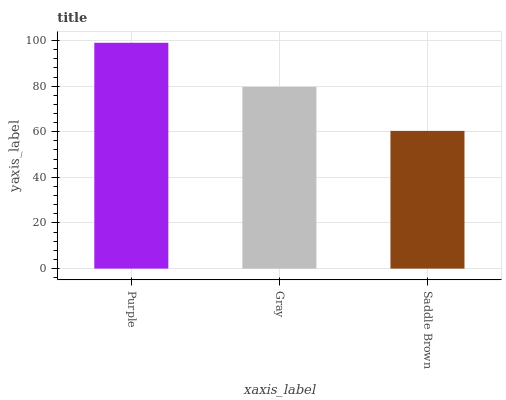Is Saddle Brown the minimum?
Answer yes or no. Yes. Is Purple the maximum?
Answer yes or no. Yes. Is Gray the minimum?
Answer yes or no. No. Is Gray the maximum?
Answer yes or no. No. Is Purple greater than Gray?
Answer yes or no. Yes. Is Gray less than Purple?
Answer yes or no. Yes. Is Gray greater than Purple?
Answer yes or no. No. Is Purple less than Gray?
Answer yes or no. No. Is Gray the high median?
Answer yes or no. Yes. Is Gray the low median?
Answer yes or no. Yes. Is Saddle Brown the high median?
Answer yes or no. No. Is Purple the low median?
Answer yes or no. No. 